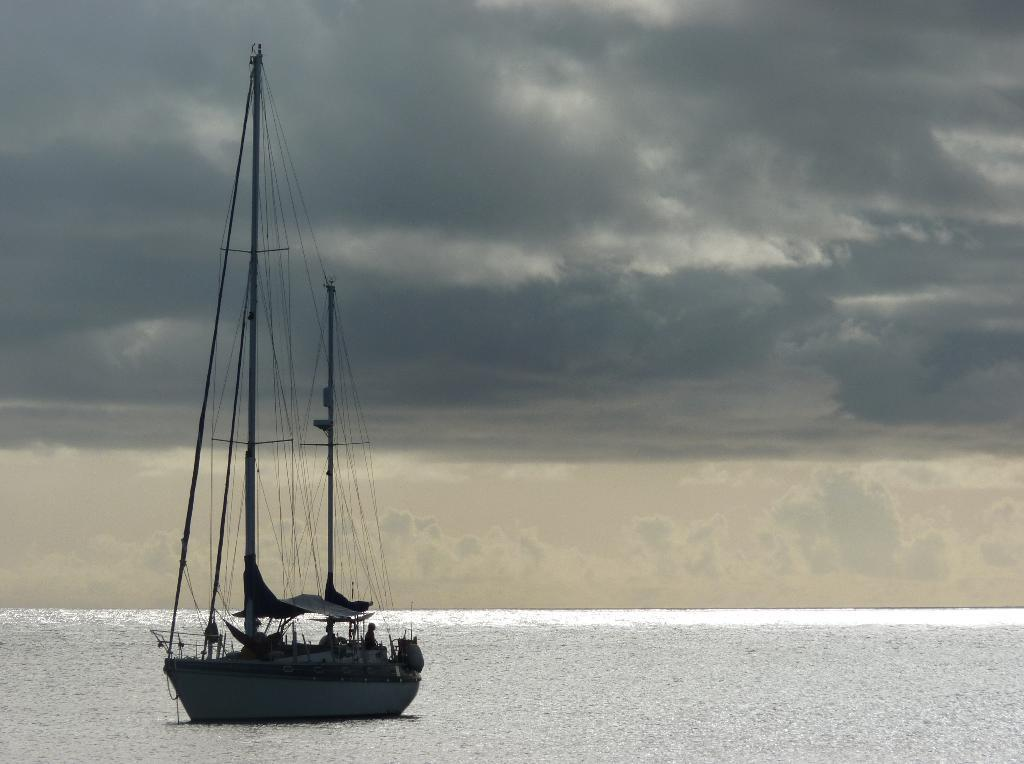What is the main subject of the image? The main subject of the image is people on a boat. What type of environment is visible in the image? There is water and sky visible in the image. What can be seen in the sky in the image? There are clouds visible in the image. Where is the playground located in the image? There is no playground present in the image. What type of lip product is the person wearing in the image? There are no people wearing lip products in the image. 